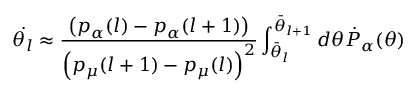<formula> <loc_0><loc_0><loc_500><loc_500>\dot { \theta _ { l } } \approx \frac { \left ( p _ { \alpha } ( l ) - p _ { \alpha } ( l + 1 ) \right ) } { \left ( p _ { \mu } ( l + 1 ) - p _ { \mu } ( l ) \right ) ^ { 2 } } \int _ { \bar { \theta } _ { l } } ^ { \bar { \theta } _ { l + 1 } } d \theta \dot { P } _ { \alpha } ( \theta )</formula> 